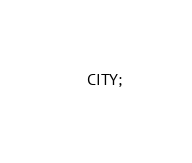<code> <loc_0><loc_0><loc_500><loc_500><_SQL_>    CITY;</code> 